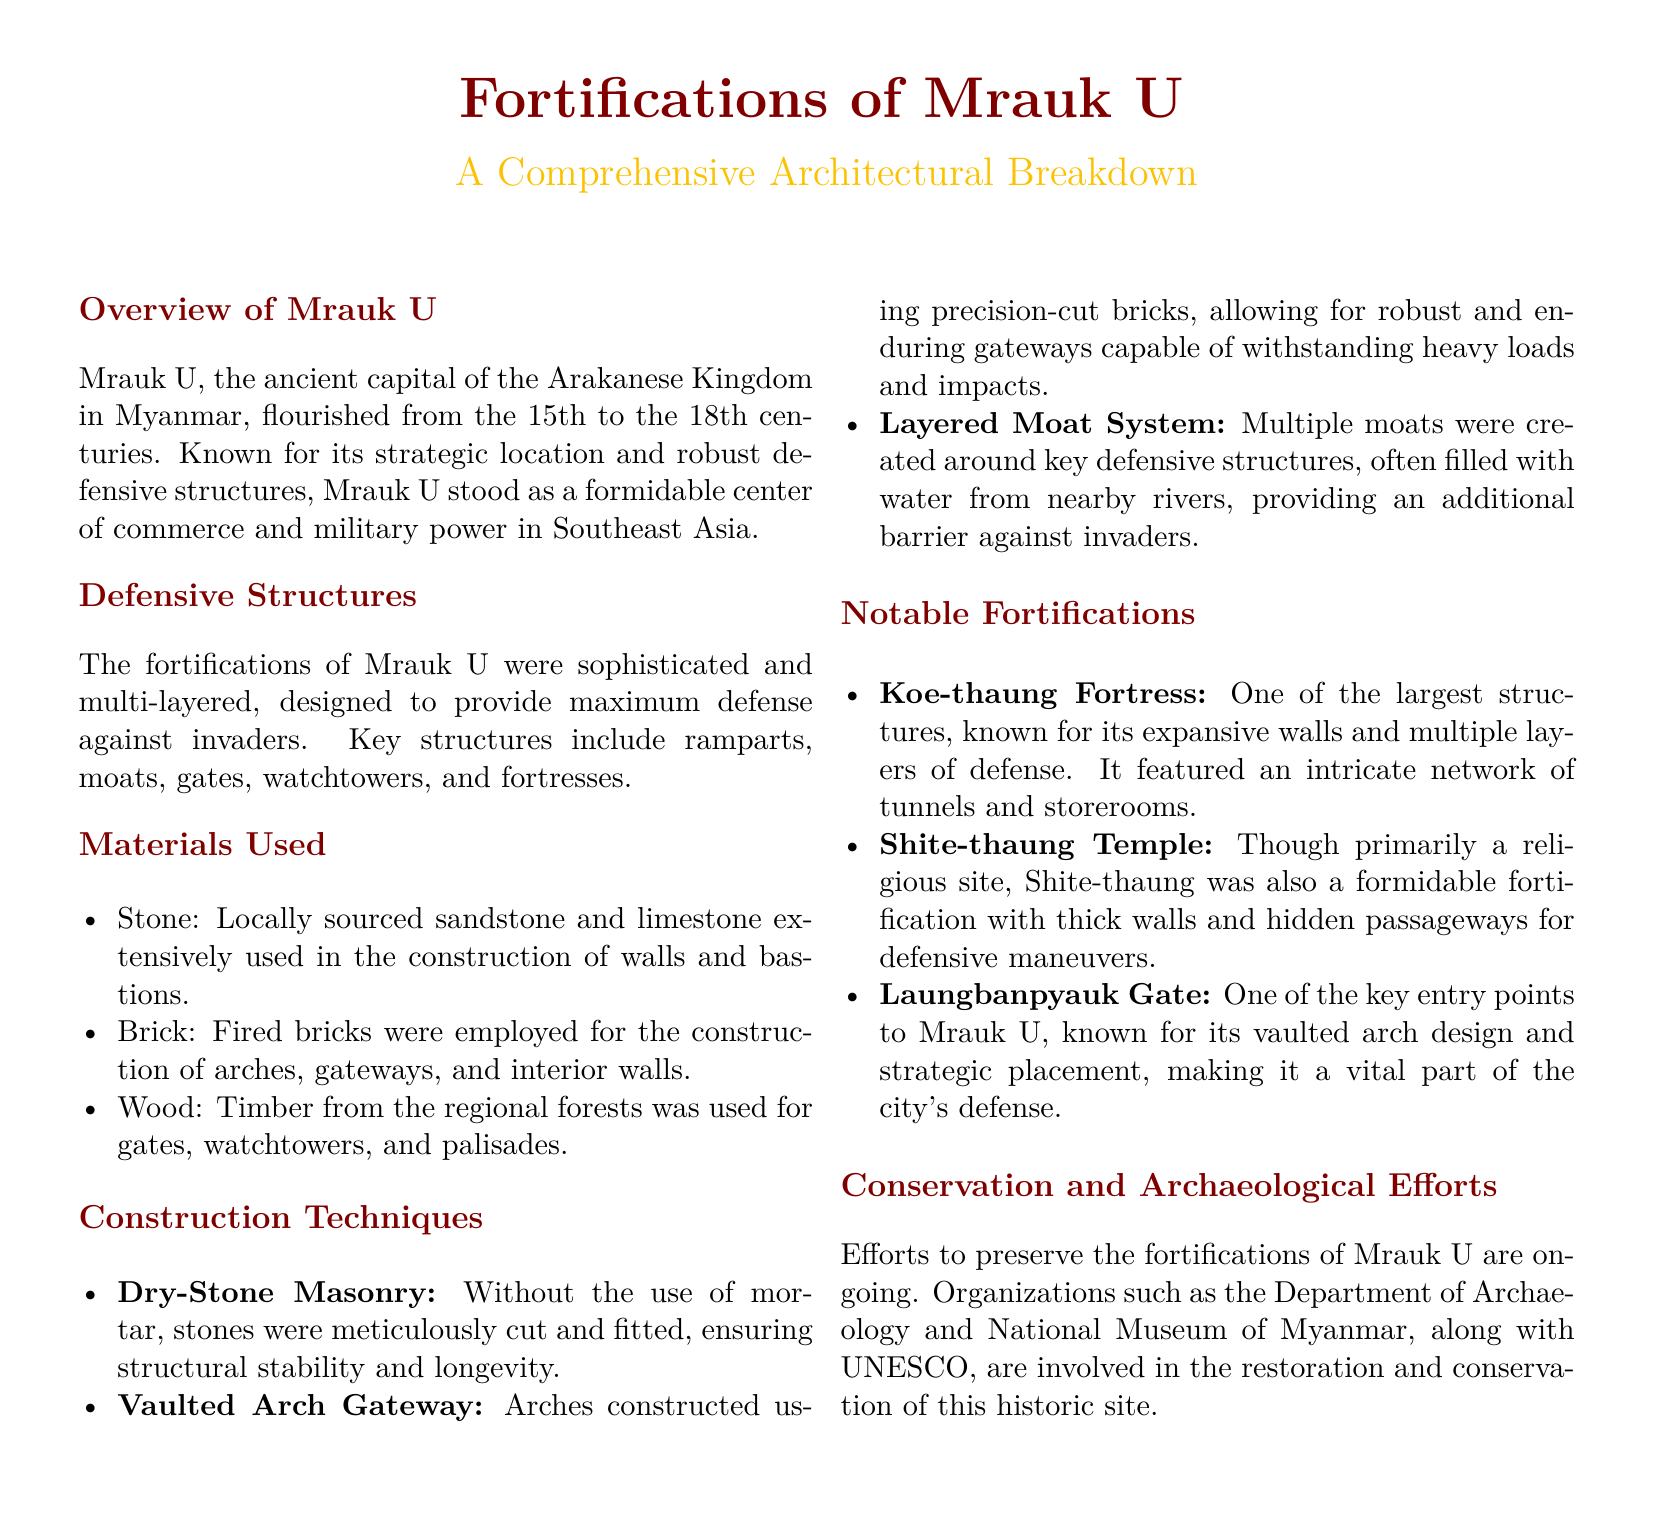What was the time period during which Mrauk U flourished? Mrauk U flourished from the 15th to the 18th centuries, as stated in the overview.
Answer: 15th to 18th centuries What materials were used for the construction of walls and bastions? The document lists locally sourced sandstone and limestone as key materials used in the construction of walls and bastions.
Answer: Stone What technique was used for creating vaulted arch gateways? The document states that precision-cut bricks were used for constructing vaulted arches, indicating a specific construction technique.
Answer: Vaulted Arch Gateway Which fortress features an intricate network of tunnels and storerooms? The Koe-thaung Fortress is noted for its expansive walls and intricate network of tunnels and storerooms.
Answer: Koe-thaung Fortress What organization is involved in the preservation of Mrauk U's fortifications? The Department of Archaeology and National Museum of Myanmar is mentioned as one of the organizations involved in the restoration efforts.
Answer: Department of Archaeology Why were multiple moats created around the defensive structures? The document explains that multiple moats provided an additional barrier against invaders, indicating their strategic importance.
Answer: Additional barrier against invaders What is the primary function of the Shite-thaung Temple? Although Shite-thaung is described as primarily a religious site, it also served as a fortification.
Answer: Religious site Which structure is known for its vaulted arch design? The Laungbanpyauk Gate is specifically mentioned for having a vaulted arch design, linking it to the city's defense.
Answer: Laungbanpyauk Gate 